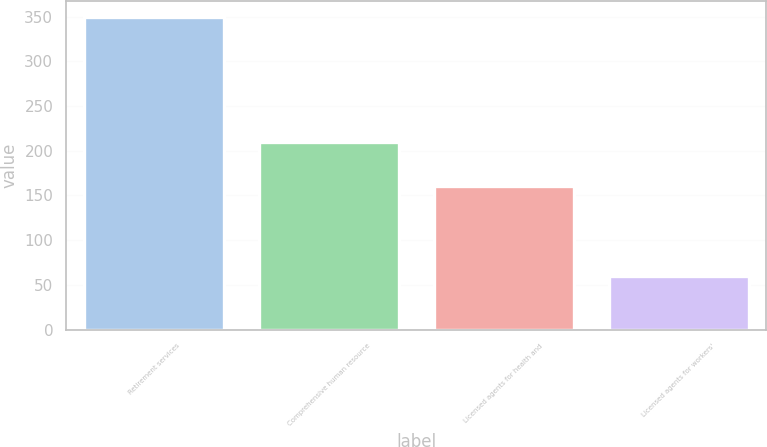Convert chart to OTSL. <chart><loc_0><loc_0><loc_500><loc_500><bar_chart><fcel>Retirement services<fcel>Comprehensive human resource<fcel>Licensed agents for health and<fcel>Licensed agents for workers'<nl><fcel>350<fcel>210<fcel>160<fcel>60<nl></chart> 